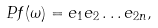<formula> <loc_0><loc_0><loc_500><loc_500>P f ( \omega ) = e _ { 1 } e _ { 2 } \dots e _ { 2 n } ,</formula> 